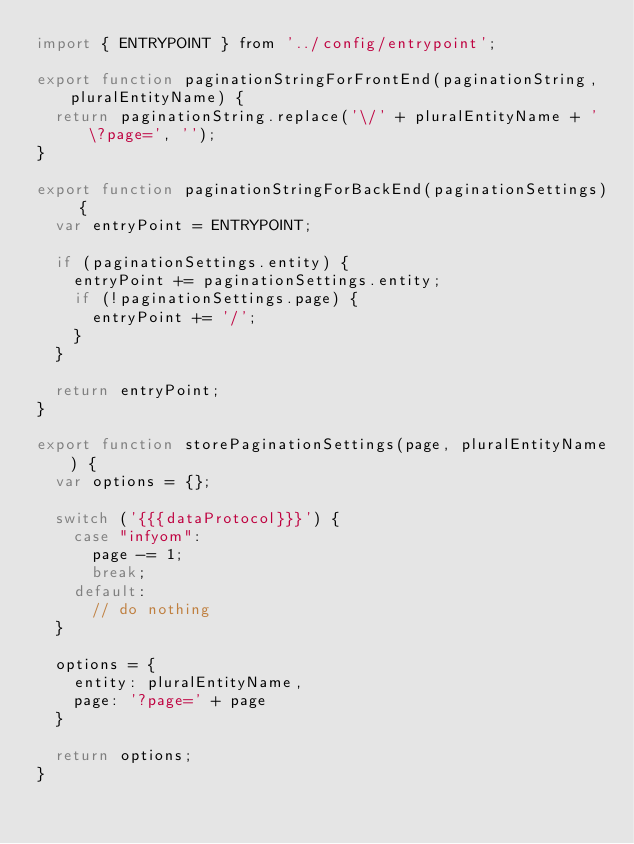<code> <loc_0><loc_0><loc_500><loc_500><_JavaScript_>import { ENTRYPOINT } from '../config/entrypoint';

export function paginationStringForFrontEnd(paginationString, pluralEntityName) {
  return paginationString.replace('\/' + pluralEntityName + '\?page=', '');
}

export function paginationStringForBackEnd(paginationSettings) {
  var entryPoint = ENTRYPOINT;

  if (paginationSettings.entity) {
    entryPoint += paginationSettings.entity;
    if (!paginationSettings.page) {
      entryPoint += '/';
    }
  }

  return entryPoint;
}

export function storePaginationSettings(page, pluralEntityName) {
  var options = {};

  switch ('{{{dataProtocol}}}') {
    case "infyom":
      page -= 1;
      break;
    default:
      // do nothing
  }

  options = {
    entity: pluralEntityName,
    page: '?page=' + page
  }

  return options;
}
</code> 